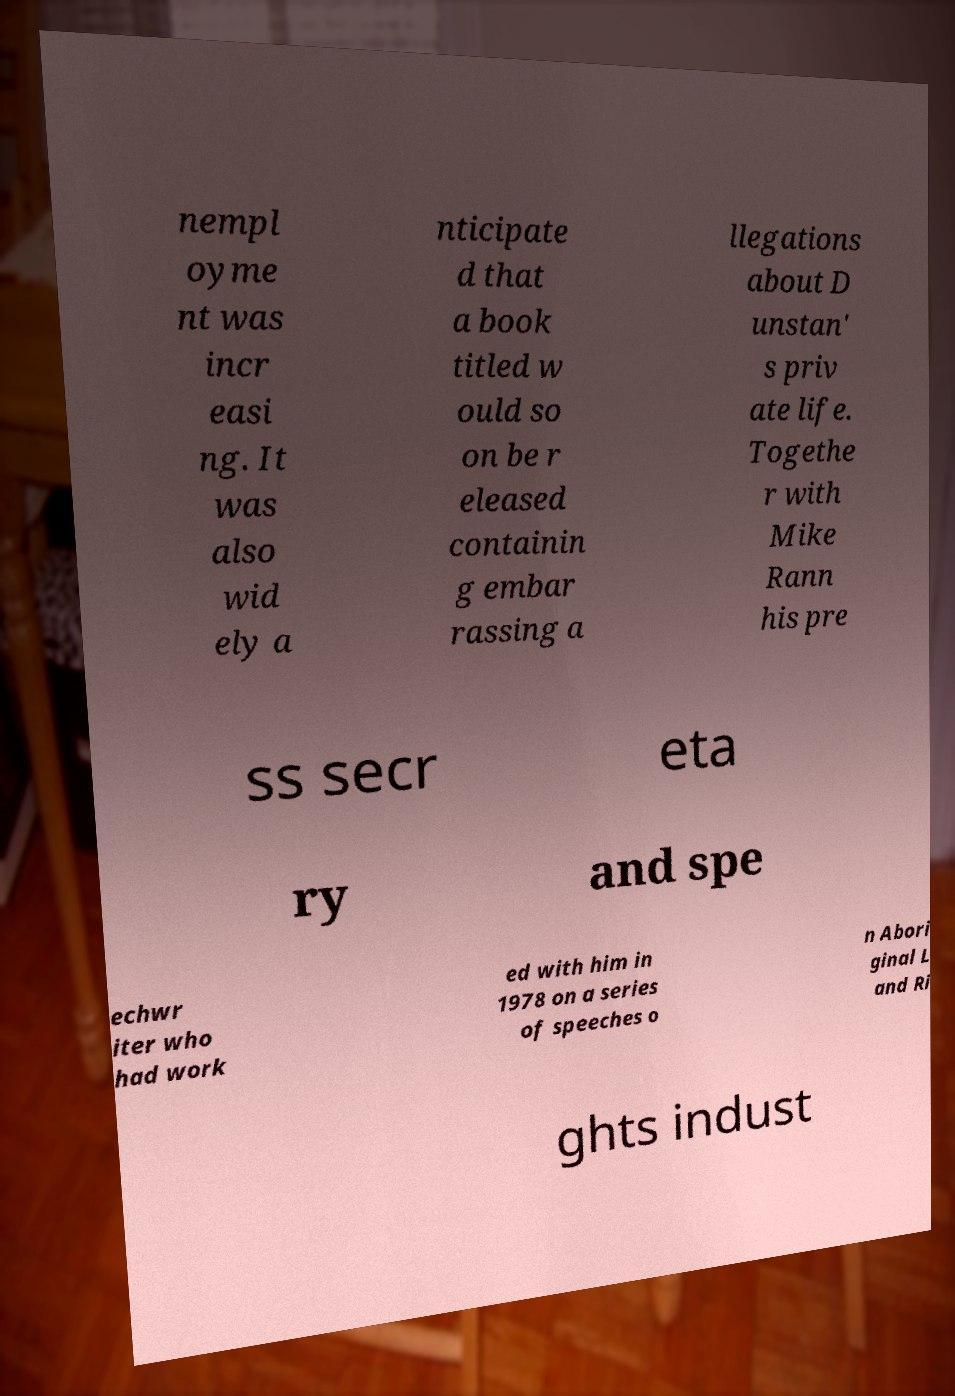Can you accurately transcribe the text from the provided image for me? nempl oyme nt was incr easi ng. It was also wid ely a nticipate d that a book titled w ould so on be r eleased containin g embar rassing a llegations about D unstan' s priv ate life. Togethe r with Mike Rann his pre ss secr eta ry and spe echwr iter who had work ed with him in 1978 on a series of speeches o n Abori ginal L and Ri ghts indust 